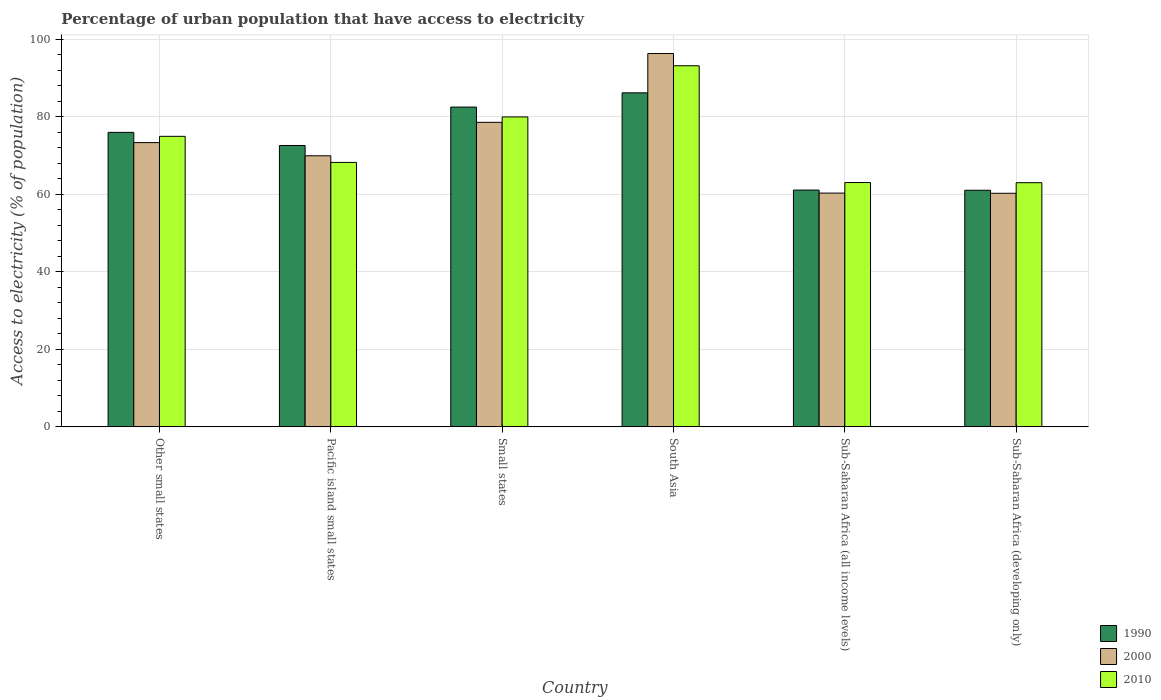How many bars are there on the 4th tick from the left?
Offer a terse response. 3. How many bars are there on the 1st tick from the right?
Provide a short and direct response. 3. What is the label of the 2nd group of bars from the left?
Offer a terse response. Pacific island small states. What is the percentage of urban population that have access to electricity in 2000 in Sub-Saharan Africa (all income levels)?
Make the answer very short. 60.28. Across all countries, what is the maximum percentage of urban population that have access to electricity in 1990?
Give a very brief answer. 86.12. Across all countries, what is the minimum percentage of urban population that have access to electricity in 2000?
Keep it short and to the point. 60.23. In which country was the percentage of urban population that have access to electricity in 2000 minimum?
Provide a succinct answer. Sub-Saharan Africa (developing only). What is the total percentage of urban population that have access to electricity in 2000 in the graph?
Make the answer very short. 438.47. What is the difference between the percentage of urban population that have access to electricity in 1990 in Other small states and that in Pacific island small states?
Offer a terse response. 3.38. What is the difference between the percentage of urban population that have access to electricity in 2000 in Sub-Saharan Africa (developing only) and the percentage of urban population that have access to electricity in 1990 in Small states?
Make the answer very short. -22.22. What is the average percentage of urban population that have access to electricity in 1990 per country?
Your response must be concise. 73.19. What is the difference between the percentage of urban population that have access to electricity of/in 1990 and percentage of urban population that have access to electricity of/in 2000 in Pacific island small states?
Make the answer very short. 2.66. What is the ratio of the percentage of urban population that have access to electricity in 1990 in Other small states to that in South Asia?
Your answer should be compact. 0.88. Is the percentage of urban population that have access to electricity in 2010 in Small states less than that in Sub-Saharan Africa (all income levels)?
Provide a short and direct response. No. What is the difference between the highest and the second highest percentage of urban population that have access to electricity in 2000?
Ensure brevity in your answer.  22.96. What is the difference between the highest and the lowest percentage of urban population that have access to electricity in 2000?
Offer a terse response. 36.03. In how many countries, is the percentage of urban population that have access to electricity in 2010 greater than the average percentage of urban population that have access to electricity in 2010 taken over all countries?
Keep it short and to the point. 3. What does the 3rd bar from the left in Sub-Saharan Africa (developing only) represents?
Offer a terse response. 2010. How many bars are there?
Keep it short and to the point. 18. Are the values on the major ticks of Y-axis written in scientific E-notation?
Your response must be concise. No. Does the graph contain any zero values?
Your answer should be compact. No. How many legend labels are there?
Offer a terse response. 3. How are the legend labels stacked?
Provide a short and direct response. Vertical. What is the title of the graph?
Give a very brief answer. Percentage of urban population that have access to electricity. What is the label or title of the X-axis?
Keep it short and to the point. Country. What is the label or title of the Y-axis?
Make the answer very short. Access to electricity (% of population). What is the Access to electricity (% of population) in 1990 in Other small states?
Give a very brief answer. 75.93. What is the Access to electricity (% of population) of 2000 in Other small states?
Offer a very short reply. 73.29. What is the Access to electricity (% of population) in 2010 in Other small states?
Ensure brevity in your answer.  74.91. What is the Access to electricity (% of population) in 1990 in Pacific island small states?
Offer a very short reply. 72.55. What is the Access to electricity (% of population) in 2000 in Pacific island small states?
Make the answer very short. 69.89. What is the Access to electricity (% of population) of 2010 in Pacific island small states?
Give a very brief answer. 68.18. What is the Access to electricity (% of population) in 1990 in Small states?
Offer a terse response. 82.45. What is the Access to electricity (% of population) in 2000 in Small states?
Offer a very short reply. 78.52. What is the Access to electricity (% of population) in 2010 in Small states?
Provide a short and direct response. 79.91. What is the Access to electricity (% of population) in 1990 in South Asia?
Make the answer very short. 86.12. What is the Access to electricity (% of population) of 2000 in South Asia?
Your response must be concise. 96.26. What is the Access to electricity (% of population) in 2010 in South Asia?
Give a very brief answer. 93.1. What is the Access to electricity (% of population) in 1990 in Sub-Saharan Africa (all income levels)?
Provide a short and direct response. 61.05. What is the Access to electricity (% of population) in 2000 in Sub-Saharan Africa (all income levels)?
Provide a succinct answer. 60.28. What is the Access to electricity (% of population) in 2010 in Sub-Saharan Africa (all income levels)?
Your response must be concise. 62.99. What is the Access to electricity (% of population) in 1990 in Sub-Saharan Africa (developing only)?
Offer a terse response. 61.01. What is the Access to electricity (% of population) of 2000 in Sub-Saharan Africa (developing only)?
Ensure brevity in your answer.  60.23. What is the Access to electricity (% of population) of 2010 in Sub-Saharan Africa (developing only)?
Provide a succinct answer. 62.95. Across all countries, what is the maximum Access to electricity (% of population) in 1990?
Ensure brevity in your answer.  86.12. Across all countries, what is the maximum Access to electricity (% of population) of 2000?
Offer a very short reply. 96.26. Across all countries, what is the maximum Access to electricity (% of population) in 2010?
Your response must be concise. 93.1. Across all countries, what is the minimum Access to electricity (% of population) of 1990?
Your answer should be compact. 61.01. Across all countries, what is the minimum Access to electricity (% of population) in 2000?
Make the answer very short. 60.23. Across all countries, what is the minimum Access to electricity (% of population) in 2010?
Make the answer very short. 62.95. What is the total Access to electricity (% of population) of 1990 in the graph?
Provide a short and direct response. 439.12. What is the total Access to electricity (% of population) in 2000 in the graph?
Your answer should be compact. 438.47. What is the total Access to electricity (% of population) in 2010 in the graph?
Offer a very short reply. 442.06. What is the difference between the Access to electricity (% of population) in 1990 in Other small states and that in Pacific island small states?
Your response must be concise. 3.38. What is the difference between the Access to electricity (% of population) in 2000 in Other small states and that in Pacific island small states?
Your answer should be compact. 3.4. What is the difference between the Access to electricity (% of population) in 2010 in Other small states and that in Pacific island small states?
Provide a short and direct response. 6.72. What is the difference between the Access to electricity (% of population) in 1990 in Other small states and that in Small states?
Your answer should be compact. -6.52. What is the difference between the Access to electricity (% of population) of 2000 in Other small states and that in Small states?
Offer a very short reply. -5.23. What is the difference between the Access to electricity (% of population) in 2010 in Other small states and that in Small states?
Offer a terse response. -5. What is the difference between the Access to electricity (% of population) in 1990 in Other small states and that in South Asia?
Keep it short and to the point. -10.19. What is the difference between the Access to electricity (% of population) of 2000 in Other small states and that in South Asia?
Your answer should be compact. -22.96. What is the difference between the Access to electricity (% of population) in 2010 in Other small states and that in South Asia?
Keep it short and to the point. -18.2. What is the difference between the Access to electricity (% of population) of 1990 in Other small states and that in Sub-Saharan Africa (all income levels)?
Give a very brief answer. 14.88. What is the difference between the Access to electricity (% of population) in 2000 in Other small states and that in Sub-Saharan Africa (all income levels)?
Your answer should be compact. 13.01. What is the difference between the Access to electricity (% of population) of 2010 in Other small states and that in Sub-Saharan Africa (all income levels)?
Keep it short and to the point. 11.91. What is the difference between the Access to electricity (% of population) in 1990 in Other small states and that in Sub-Saharan Africa (developing only)?
Ensure brevity in your answer.  14.93. What is the difference between the Access to electricity (% of population) in 2000 in Other small states and that in Sub-Saharan Africa (developing only)?
Offer a very short reply. 13.06. What is the difference between the Access to electricity (% of population) in 2010 in Other small states and that in Sub-Saharan Africa (developing only)?
Your answer should be compact. 11.95. What is the difference between the Access to electricity (% of population) in 1990 in Pacific island small states and that in Small states?
Your answer should be very brief. -9.9. What is the difference between the Access to electricity (% of population) of 2000 in Pacific island small states and that in Small states?
Offer a very short reply. -8.63. What is the difference between the Access to electricity (% of population) of 2010 in Pacific island small states and that in Small states?
Your answer should be very brief. -11.73. What is the difference between the Access to electricity (% of population) of 1990 in Pacific island small states and that in South Asia?
Provide a succinct answer. -13.57. What is the difference between the Access to electricity (% of population) in 2000 in Pacific island small states and that in South Asia?
Offer a terse response. -26.36. What is the difference between the Access to electricity (% of population) in 2010 in Pacific island small states and that in South Asia?
Provide a succinct answer. -24.92. What is the difference between the Access to electricity (% of population) in 1990 in Pacific island small states and that in Sub-Saharan Africa (all income levels)?
Provide a short and direct response. 11.5. What is the difference between the Access to electricity (% of population) of 2000 in Pacific island small states and that in Sub-Saharan Africa (all income levels)?
Provide a short and direct response. 9.62. What is the difference between the Access to electricity (% of population) in 2010 in Pacific island small states and that in Sub-Saharan Africa (all income levels)?
Ensure brevity in your answer.  5.19. What is the difference between the Access to electricity (% of population) of 1990 in Pacific island small states and that in Sub-Saharan Africa (developing only)?
Keep it short and to the point. 11.54. What is the difference between the Access to electricity (% of population) in 2000 in Pacific island small states and that in Sub-Saharan Africa (developing only)?
Keep it short and to the point. 9.66. What is the difference between the Access to electricity (% of population) in 2010 in Pacific island small states and that in Sub-Saharan Africa (developing only)?
Ensure brevity in your answer.  5.23. What is the difference between the Access to electricity (% of population) of 1990 in Small states and that in South Asia?
Ensure brevity in your answer.  -3.67. What is the difference between the Access to electricity (% of population) in 2000 in Small states and that in South Asia?
Give a very brief answer. -17.74. What is the difference between the Access to electricity (% of population) of 2010 in Small states and that in South Asia?
Make the answer very short. -13.19. What is the difference between the Access to electricity (% of population) of 1990 in Small states and that in Sub-Saharan Africa (all income levels)?
Provide a succinct answer. 21.4. What is the difference between the Access to electricity (% of population) in 2000 in Small states and that in Sub-Saharan Africa (all income levels)?
Your response must be concise. 18.24. What is the difference between the Access to electricity (% of population) of 2010 in Small states and that in Sub-Saharan Africa (all income levels)?
Your answer should be compact. 16.92. What is the difference between the Access to electricity (% of population) in 1990 in Small states and that in Sub-Saharan Africa (developing only)?
Your answer should be very brief. 21.45. What is the difference between the Access to electricity (% of population) of 2000 in Small states and that in Sub-Saharan Africa (developing only)?
Provide a succinct answer. 18.29. What is the difference between the Access to electricity (% of population) in 2010 in Small states and that in Sub-Saharan Africa (developing only)?
Your response must be concise. 16.96. What is the difference between the Access to electricity (% of population) in 1990 in South Asia and that in Sub-Saharan Africa (all income levels)?
Your answer should be very brief. 25.07. What is the difference between the Access to electricity (% of population) in 2000 in South Asia and that in Sub-Saharan Africa (all income levels)?
Ensure brevity in your answer.  35.98. What is the difference between the Access to electricity (% of population) of 2010 in South Asia and that in Sub-Saharan Africa (all income levels)?
Your answer should be compact. 30.11. What is the difference between the Access to electricity (% of population) in 1990 in South Asia and that in Sub-Saharan Africa (developing only)?
Your answer should be very brief. 25.12. What is the difference between the Access to electricity (% of population) of 2000 in South Asia and that in Sub-Saharan Africa (developing only)?
Provide a succinct answer. 36.03. What is the difference between the Access to electricity (% of population) of 2010 in South Asia and that in Sub-Saharan Africa (developing only)?
Your answer should be compact. 30.15. What is the difference between the Access to electricity (% of population) in 1990 in Sub-Saharan Africa (all income levels) and that in Sub-Saharan Africa (developing only)?
Ensure brevity in your answer.  0.05. What is the difference between the Access to electricity (% of population) of 2000 in Sub-Saharan Africa (all income levels) and that in Sub-Saharan Africa (developing only)?
Make the answer very short. 0.05. What is the difference between the Access to electricity (% of population) of 1990 in Other small states and the Access to electricity (% of population) of 2000 in Pacific island small states?
Give a very brief answer. 6.04. What is the difference between the Access to electricity (% of population) of 1990 in Other small states and the Access to electricity (% of population) of 2010 in Pacific island small states?
Offer a terse response. 7.75. What is the difference between the Access to electricity (% of population) in 2000 in Other small states and the Access to electricity (% of population) in 2010 in Pacific island small states?
Offer a very short reply. 5.11. What is the difference between the Access to electricity (% of population) of 1990 in Other small states and the Access to electricity (% of population) of 2000 in Small states?
Provide a succinct answer. -2.59. What is the difference between the Access to electricity (% of population) in 1990 in Other small states and the Access to electricity (% of population) in 2010 in Small states?
Make the answer very short. -3.98. What is the difference between the Access to electricity (% of population) of 2000 in Other small states and the Access to electricity (% of population) of 2010 in Small states?
Provide a succinct answer. -6.62. What is the difference between the Access to electricity (% of population) in 1990 in Other small states and the Access to electricity (% of population) in 2000 in South Asia?
Your answer should be compact. -20.32. What is the difference between the Access to electricity (% of population) in 1990 in Other small states and the Access to electricity (% of population) in 2010 in South Asia?
Give a very brief answer. -17.17. What is the difference between the Access to electricity (% of population) in 2000 in Other small states and the Access to electricity (% of population) in 2010 in South Asia?
Your response must be concise. -19.81. What is the difference between the Access to electricity (% of population) in 1990 in Other small states and the Access to electricity (% of population) in 2000 in Sub-Saharan Africa (all income levels)?
Offer a very short reply. 15.65. What is the difference between the Access to electricity (% of population) in 1990 in Other small states and the Access to electricity (% of population) in 2010 in Sub-Saharan Africa (all income levels)?
Make the answer very short. 12.94. What is the difference between the Access to electricity (% of population) of 2000 in Other small states and the Access to electricity (% of population) of 2010 in Sub-Saharan Africa (all income levels)?
Offer a terse response. 10.3. What is the difference between the Access to electricity (% of population) in 1990 in Other small states and the Access to electricity (% of population) in 2000 in Sub-Saharan Africa (developing only)?
Offer a very short reply. 15.7. What is the difference between the Access to electricity (% of population) of 1990 in Other small states and the Access to electricity (% of population) of 2010 in Sub-Saharan Africa (developing only)?
Provide a short and direct response. 12.98. What is the difference between the Access to electricity (% of population) in 2000 in Other small states and the Access to electricity (% of population) in 2010 in Sub-Saharan Africa (developing only)?
Make the answer very short. 10.34. What is the difference between the Access to electricity (% of population) of 1990 in Pacific island small states and the Access to electricity (% of population) of 2000 in Small states?
Your answer should be compact. -5.97. What is the difference between the Access to electricity (% of population) of 1990 in Pacific island small states and the Access to electricity (% of population) of 2010 in Small states?
Keep it short and to the point. -7.36. What is the difference between the Access to electricity (% of population) of 2000 in Pacific island small states and the Access to electricity (% of population) of 2010 in Small states?
Make the answer very short. -10.02. What is the difference between the Access to electricity (% of population) of 1990 in Pacific island small states and the Access to electricity (% of population) of 2000 in South Asia?
Ensure brevity in your answer.  -23.71. What is the difference between the Access to electricity (% of population) of 1990 in Pacific island small states and the Access to electricity (% of population) of 2010 in South Asia?
Offer a very short reply. -20.55. What is the difference between the Access to electricity (% of population) of 2000 in Pacific island small states and the Access to electricity (% of population) of 2010 in South Asia?
Make the answer very short. -23.21. What is the difference between the Access to electricity (% of population) of 1990 in Pacific island small states and the Access to electricity (% of population) of 2000 in Sub-Saharan Africa (all income levels)?
Offer a terse response. 12.27. What is the difference between the Access to electricity (% of population) of 1990 in Pacific island small states and the Access to electricity (% of population) of 2010 in Sub-Saharan Africa (all income levels)?
Provide a succinct answer. 9.56. What is the difference between the Access to electricity (% of population) of 2000 in Pacific island small states and the Access to electricity (% of population) of 2010 in Sub-Saharan Africa (all income levels)?
Make the answer very short. 6.9. What is the difference between the Access to electricity (% of population) in 1990 in Pacific island small states and the Access to electricity (% of population) in 2000 in Sub-Saharan Africa (developing only)?
Provide a succinct answer. 12.32. What is the difference between the Access to electricity (% of population) in 1990 in Pacific island small states and the Access to electricity (% of population) in 2010 in Sub-Saharan Africa (developing only)?
Your answer should be compact. 9.6. What is the difference between the Access to electricity (% of population) of 2000 in Pacific island small states and the Access to electricity (% of population) of 2010 in Sub-Saharan Africa (developing only)?
Keep it short and to the point. 6.94. What is the difference between the Access to electricity (% of population) in 1990 in Small states and the Access to electricity (% of population) in 2000 in South Asia?
Offer a terse response. -13.8. What is the difference between the Access to electricity (% of population) of 1990 in Small states and the Access to electricity (% of population) of 2010 in South Asia?
Provide a short and direct response. -10.65. What is the difference between the Access to electricity (% of population) of 2000 in Small states and the Access to electricity (% of population) of 2010 in South Asia?
Your answer should be compact. -14.58. What is the difference between the Access to electricity (% of population) in 1990 in Small states and the Access to electricity (% of population) in 2000 in Sub-Saharan Africa (all income levels)?
Your answer should be compact. 22.18. What is the difference between the Access to electricity (% of population) in 1990 in Small states and the Access to electricity (% of population) in 2010 in Sub-Saharan Africa (all income levels)?
Your answer should be very brief. 19.46. What is the difference between the Access to electricity (% of population) of 2000 in Small states and the Access to electricity (% of population) of 2010 in Sub-Saharan Africa (all income levels)?
Give a very brief answer. 15.52. What is the difference between the Access to electricity (% of population) of 1990 in Small states and the Access to electricity (% of population) of 2000 in Sub-Saharan Africa (developing only)?
Keep it short and to the point. 22.22. What is the difference between the Access to electricity (% of population) of 1990 in Small states and the Access to electricity (% of population) of 2010 in Sub-Saharan Africa (developing only)?
Provide a succinct answer. 19.5. What is the difference between the Access to electricity (% of population) of 2000 in Small states and the Access to electricity (% of population) of 2010 in Sub-Saharan Africa (developing only)?
Keep it short and to the point. 15.56. What is the difference between the Access to electricity (% of population) of 1990 in South Asia and the Access to electricity (% of population) of 2000 in Sub-Saharan Africa (all income levels)?
Your answer should be compact. 25.85. What is the difference between the Access to electricity (% of population) in 1990 in South Asia and the Access to electricity (% of population) in 2010 in Sub-Saharan Africa (all income levels)?
Your answer should be compact. 23.13. What is the difference between the Access to electricity (% of population) in 2000 in South Asia and the Access to electricity (% of population) in 2010 in Sub-Saharan Africa (all income levels)?
Your response must be concise. 33.26. What is the difference between the Access to electricity (% of population) of 1990 in South Asia and the Access to electricity (% of population) of 2000 in Sub-Saharan Africa (developing only)?
Keep it short and to the point. 25.89. What is the difference between the Access to electricity (% of population) of 1990 in South Asia and the Access to electricity (% of population) of 2010 in Sub-Saharan Africa (developing only)?
Provide a succinct answer. 23.17. What is the difference between the Access to electricity (% of population) in 2000 in South Asia and the Access to electricity (% of population) in 2010 in Sub-Saharan Africa (developing only)?
Keep it short and to the point. 33.3. What is the difference between the Access to electricity (% of population) in 1990 in Sub-Saharan Africa (all income levels) and the Access to electricity (% of population) in 2000 in Sub-Saharan Africa (developing only)?
Your answer should be very brief. 0.82. What is the difference between the Access to electricity (% of population) of 1990 in Sub-Saharan Africa (all income levels) and the Access to electricity (% of population) of 2010 in Sub-Saharan Africa (developing only)?
Keep it short and to the point. -1.9. What is the difference between the Access to electricity (% of population) in 2000 in Sub-Saharan Africa (all income levels) and the Access to electricity (% of population) in 2010 in Sub-Saharan Africa (developing only)?
Your answer should be compact. -2.68. What is the average Access to electricity (% of population) in 1990 per country?
Give a very brief answer. 73.19. What is the average Access to electricity (% of population) in 2000 per country?
Your answer should be compact. 73.08. What is the average Access to electricity (% of population) of 2010 per country?
Provide a succinct answer. 73.68. What is the difference between the Access to electricity (% of population) in 1990 and Access to electricity (% of population) in 2000 in Other small states?
Offer a terse response. 2.64. What is the difference between the Access to electricity (% of population) of 1990 and Access to electricity (% of population) of 2010 in Other small states?
Keep it short and to the point. 1.02. What is the difference between the Access to electricity (% of population) in 2000 and Access to electricity (% of population) in 2010 in Other small states?
Make the answer very short. -1.62. What is the difference between the Access to electricity (% of population) of 1990 and Access to electricity (% of population) of 2000 in Pacific island small states?
Your answer should be very brief. 2.66. What is the difference between the Access to electricity (% of population) in 1990 and Access to electricity (% of population) in 2010 in Pacific island small states?
Make the answer very short. 4.37. What is the difference between the Access to electricity (% of population) of 2000 and Access to electricity (% of population) of 2010 in Pacific island small states?
Provide a short and direct response. 1.71. What is the difference between the Access to electricity (% of population) of 1990 and Access to electricity (% of population) of 2000 in Small states?
Your response must be concise. 3.93. What is the difference between the Access to electricity (% of population) in 1990 and Access to electricity (% of population) in 2010 in Small states?
Provide a short and direct response. 2.54. What is the difference between the Access to electricity (% of population) of 2000 and Access to electricity (% of population) of 2010 in Small states?
Provide a succinct answer. -1.39. What is the difference between the Access to electricity (% of population) of 1990 and Access to electricity (% of population) of 2000 in South Asia?
Make the answer very short. -10.13. What is the difference between the Access to electricity (% of population) of 1990 and Access to electricity (% of population) of 2010 in South Asia?
Ensure brevity in your answer.  -6.98. What is the difference between the Access to electricity (% of population) in 2000 and Access to electricity (% of population) in 2010 in South Asia?
Give a very brief answer. 3.15. What is the difference between the Access to electricity (% of population) of 1990 and Access to electricity (% of population) of 2000 in Sub-Saharan Africa (all income levels)?
Your answer should be very brief. 0.78. What is the difference between the Access to electricity (% of population) in 1990 and Access to electricity (% of population) in 2010 in Sub-Saharan Africa (all income levels)?
Make the answer very short. -1.94. What is the difference between the Access to electricity (% of population) in 2000 and Access to electricity (% of population) in 2010 in Sub-Saharan Africa (all income levels)?
Your answer should be compact. -2.72. What is the difference between the Access to electricity (% of population) of 1990 and Access to electricity (% of population) of 2000 in Sub-Saharan Africa (developing only)?
Your answer should be compact. 0.78. What is the difference between the Access to electricity (% of population) in 1990 and Access to electricity (% of population) in 2010 in Sub-Saharan Africa (developing only)?
Your response must be concise. -1.95. What is the difference between the Access to electricity (% of population) in 2000 and Access to electricity (% of population) in 2010 in Sub-Saharan Africa (developing only)?
Provide a short and direct response. -2.73. What is the ratio of the Access to electricity (% of population) in 1990 in Other small states to that in Pacific island small states?
Ensure brevity in your answer.  1.05. What is the ratio of the Access to electricity (% of population) of 2000 in Other small states to that in Pacific island small states?
Make the answer very short. 1.05. What is the ratio of the Access to electricity (% of population) of 2010 in Other small states to that in Pacific island small states?
Give a very brief answer. 1.1. What is the ratio of the Access to electricity (% of population) in 1990 in Other small states to that in Small states?
Ensure brevity in your answer.  0.92. What is the ratio of the Access to electricity (% of population) in 2000 in Other small states to that in Small states?
Your answer should be very brief. 0.93. What is the ratio of the Access to electricity (% of population) in 2010 in Other small states to that in Small states?
Your response must be concise. 0.94. What is the ratio of the Access to electricity (% of population) of 1990 in Other small states to that in South Asia?
Provide a succinct answer. 0.88. What is the ratio of the Access to electricity (% of population) of 2000 in Other small states to that in South Asia?
Keep it short and to the point. 0.76. What is the ratio of the Access to electricity (% of population) in 2010 in Other small states to that in South Asia?
Offer a terse response. 0.8. What is the ratio of the Access to electricity (% of population) of 1990 in Other small states to that in Sub-Saharan Africa (all income levels)?
Provide a short and direct response. 1.24. What is the ratio of the Access to electricity (% of population) in 2000 in Other small states to that in Sub-Saharan Africa (all income levels)?
Make the answer very short. 1.22. What is the ratio of the Access to electricity (% of population) in 2010 in Other small states to that in Sub-Saharan Africa (all income levels)?
Keep it short and to the point. 1.19. What is the ratio of the Access to electricity (% of population) in 1990 in Other small states to that in Sub-Saharan Africa (developing only)?
Provide a succinct answer. 1.24. What is the ratio of the Access to electricity (% of population) of 2000 in Other small states to that in Sub-Saharan Africa (developing only)?
Offer a terse response. 1.22. What is the ratio of the Access to electricity (% of population) in 2010 in Other small states to that in Sub-Saharan Africa (developing only)?
Your answer should be compact. 1.19. What is the ratio of the Access to electricity (% of population) in 1990 in Pacific island small states to that in Small states?
Your response must be concise. 0.88. What is the ratio of the Access to electricity (% of population) in 2000 in Pacific island small states to that in Small states?
Keep it short and to the point. 0.89. What is the ratio of the Access to electricity (% of population) in 2010 in Pacific island small states to that in Small states?
Offer a terse response. 0.85. What is the ratio of the Access to electricity (% of population) in 1990 in Pacific island small states to that in South Asia?
Provide a succinct answer. 0.84. What is the ratio of the Access to electricity (% of population) of 2000 in Pacific island small states to that in South Asia?
Provide a succinct answer. 0.73. What is the ratio of the Access to electricity (% of population) of 2010 in Pacific island small states to that in South Asia?
Your answer should be very brief. 0.73. What is the ratio of the Access to electricity (% of population) in 1990 in Pacific island small states to that in Sub-Saharan Africa (all income levels)?
Provide a succinct answer. 1.19. What is the ratio of the Access to electricity (% of population) of 2000 in Pacific island small states to that in Sub-Saharan Africa (all income levels)?
Make the answer very short. 1.16. What is the ratio of the Access to electricity (% of population) of 2010 in Pacific island small states to that in Sub-Saharan Africa (all income levels)?
Offer a terse response. 1.08. What is the ratio of the Access to electricity (% of population) in 1990 in Pacific island small states to that in Sub-Saharan Africa (developing only)?
Your response must be concise. 1.19. What is the ratio of the Access to electricity (% of population) in 2000 in Pacific island small states to that in Sub-Saharan Africa (developing only)?
Offer a terse response. 1.16. What is the ratio of the Access to electricity (% of population) in 2010 in Pacific island small states to that in Sub-Saharan Africa (developing only)?
Keep it short and to the point. 1.08. What is the ratio of the Access to electricity (% of population) in 1990 in Small states to that in South Asia?
Offer a very short reply. 0.96. What is the ratio of the Access to electricity (% of population) of 2000 in Small states to that in South Asia?
Your response must be concise. 0.82. What is the ratio of the Access to electricity (% of population) of 2010 in Small states to that in South Asia?
Your response must be concise. 0.86. What is the ratio of the Access to electricity (% of population) of 1990 in Small states to that in Sub-Saharan Africa (all income levels)?
Ensure brevity in your answer.  1.35. What is the ratio of the Access to electricity (% of population) of 2000 in Small states to that in Sub-Saharan Africa (all income levels)?
Your response must be concise. 1.3. What is the ratio of the Access to electricity (% of population) in 2010 in Small states to that in Sub-Saharan Africa (all income levels)?
Give a very brief answer. 1.27. What is the ratio of the Access to electricity (% of population) of 1990 in Small states to that in Sub-Saharan Africa (developing only)?
Offer a very short reply. 1.35. What is the ratio of the Access to electricity (% of population) in 2000 in Small states to that in Sub-Saharan Africa (developing only)?
Provide a short and direct response. 1.3. What is the ratio of the Access to electricity (% of population) in 2010 in Small states to that in Sub-Saharan Africa (developing only)?
Your answer should be very brief. 1.27. What is the ratio of the Access to electricity (% of population) of 1990 in South Asia to that in Sub-Saharan Africa (all income levels)?
Provide a short and direct response. 1.41. What is the ratio of the Access to electricity (% of population) of 2000 in South Asia to that in Sub-Saharan Africa (all income levels)?
Your answer should be compact. 1.6. What is the ratio of the Access to electricity (% of population) of 2010 in South Asia to that in Sub-Saharan Africa (all income levels)?
Your answer should be very brief. 1.48. What is the ratio of the Access to electricity (% of population) of 1990 in South Asia to that in Sub-Saharan Africa (developing only)?
Offer a very short reply. 1.41. What is the ratio of the Access to electricity (% of population) of 2000 in South Asia to that in Sub-Saharan Africa (developing only)?
Give a very brief answer. 1.6. What is the ratio of the Access to electricity (% of population) in 2010 in South Asia to that in Sub-Saharan Africa (developing only)?
Provide a succinct answer. 1.48. What is the ratio of the Access to electricity (% of population) of 2000 in Sub-Saharan Africa (all income levels) to that in Sub-Saharan Africa (developing only)?
Your answer should be compact. 1. What is the difference between the highest and the second highest Access to electricity (% of population) in 1990?
Your answer should be compact. 3.67. What is the difference between the highest and the second highest Access to electricity (% of population) in 2000?
Offer a terse response. 17.74. What is the difference between the highest and the second highest Access to electricity (% of population) in 2010?
Your answer should be very brief. 13.19. What is the difference between the highest and the lowest Access to electricity (% of population) of 1990?
Keep it short and to the point. 25.12. What is the difference between the highest and the lowest Access to electricity (% of population) in 2000?
Your response must be concise. 36.03. What is the difference between the highest and the lowest Access to electricity (% of population) in 2010?
Provide a short and direct response. 30.15. 